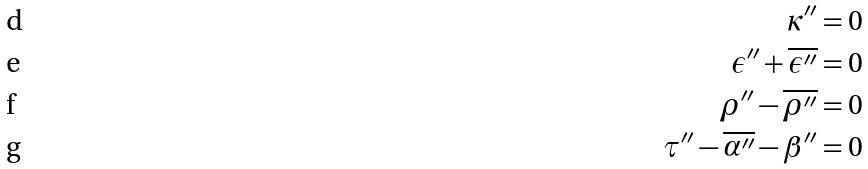Convert formula to latex. <formula><loc_0><loc_0><loc_500><loc_500>\kappa ^ { \prime \prime } & = 0 \\ \epsilon ^ { \prime \prime } + \overline { \epsilon ^ { \prime \prime } } & = 0 \\ \rho ^ { \prime \prime } - \overline { \rho ^ { \prime \prime } } & = 0 \\ \tau ^ { \prime \prime } - \overline { \alpha ^ { \prime \prime } } - \beta ^ { \prime \prime } & = 0</formula> 